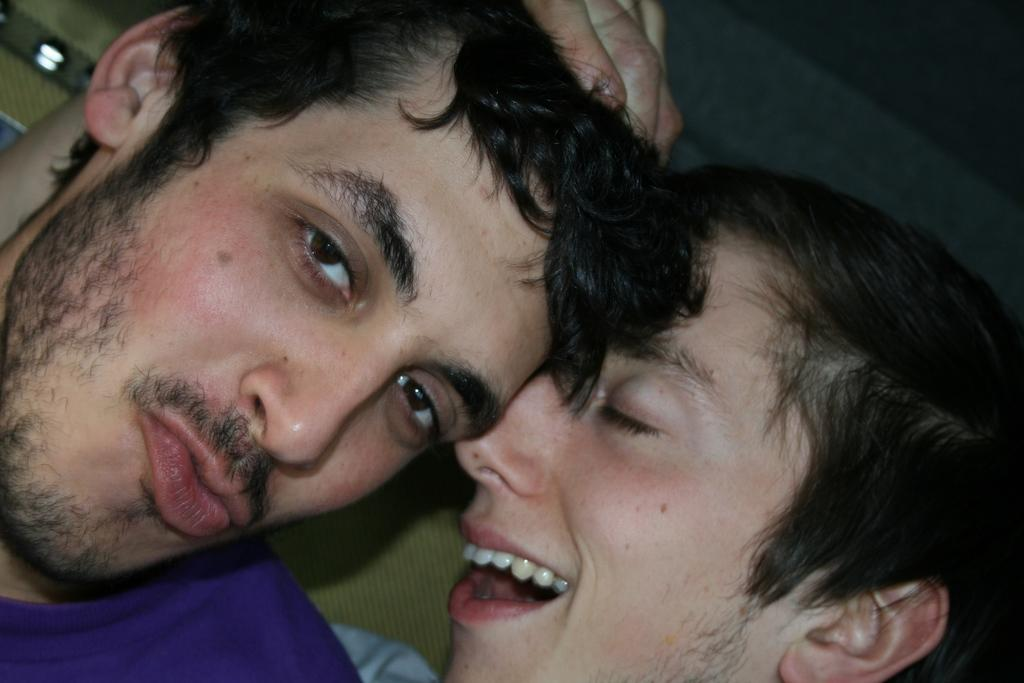Who or what can be seen in the image? There are people in the image. What can be seen in the background of the image? There are lights visible in the background of the image. How many spiders are crawling on the people in the image? There are no spiders visible in the image; it only features people and lights in the background. What route are the people taking in the image? The image does not provide information about the route the people are taking, as it only shows their presence and the lights in the background. 